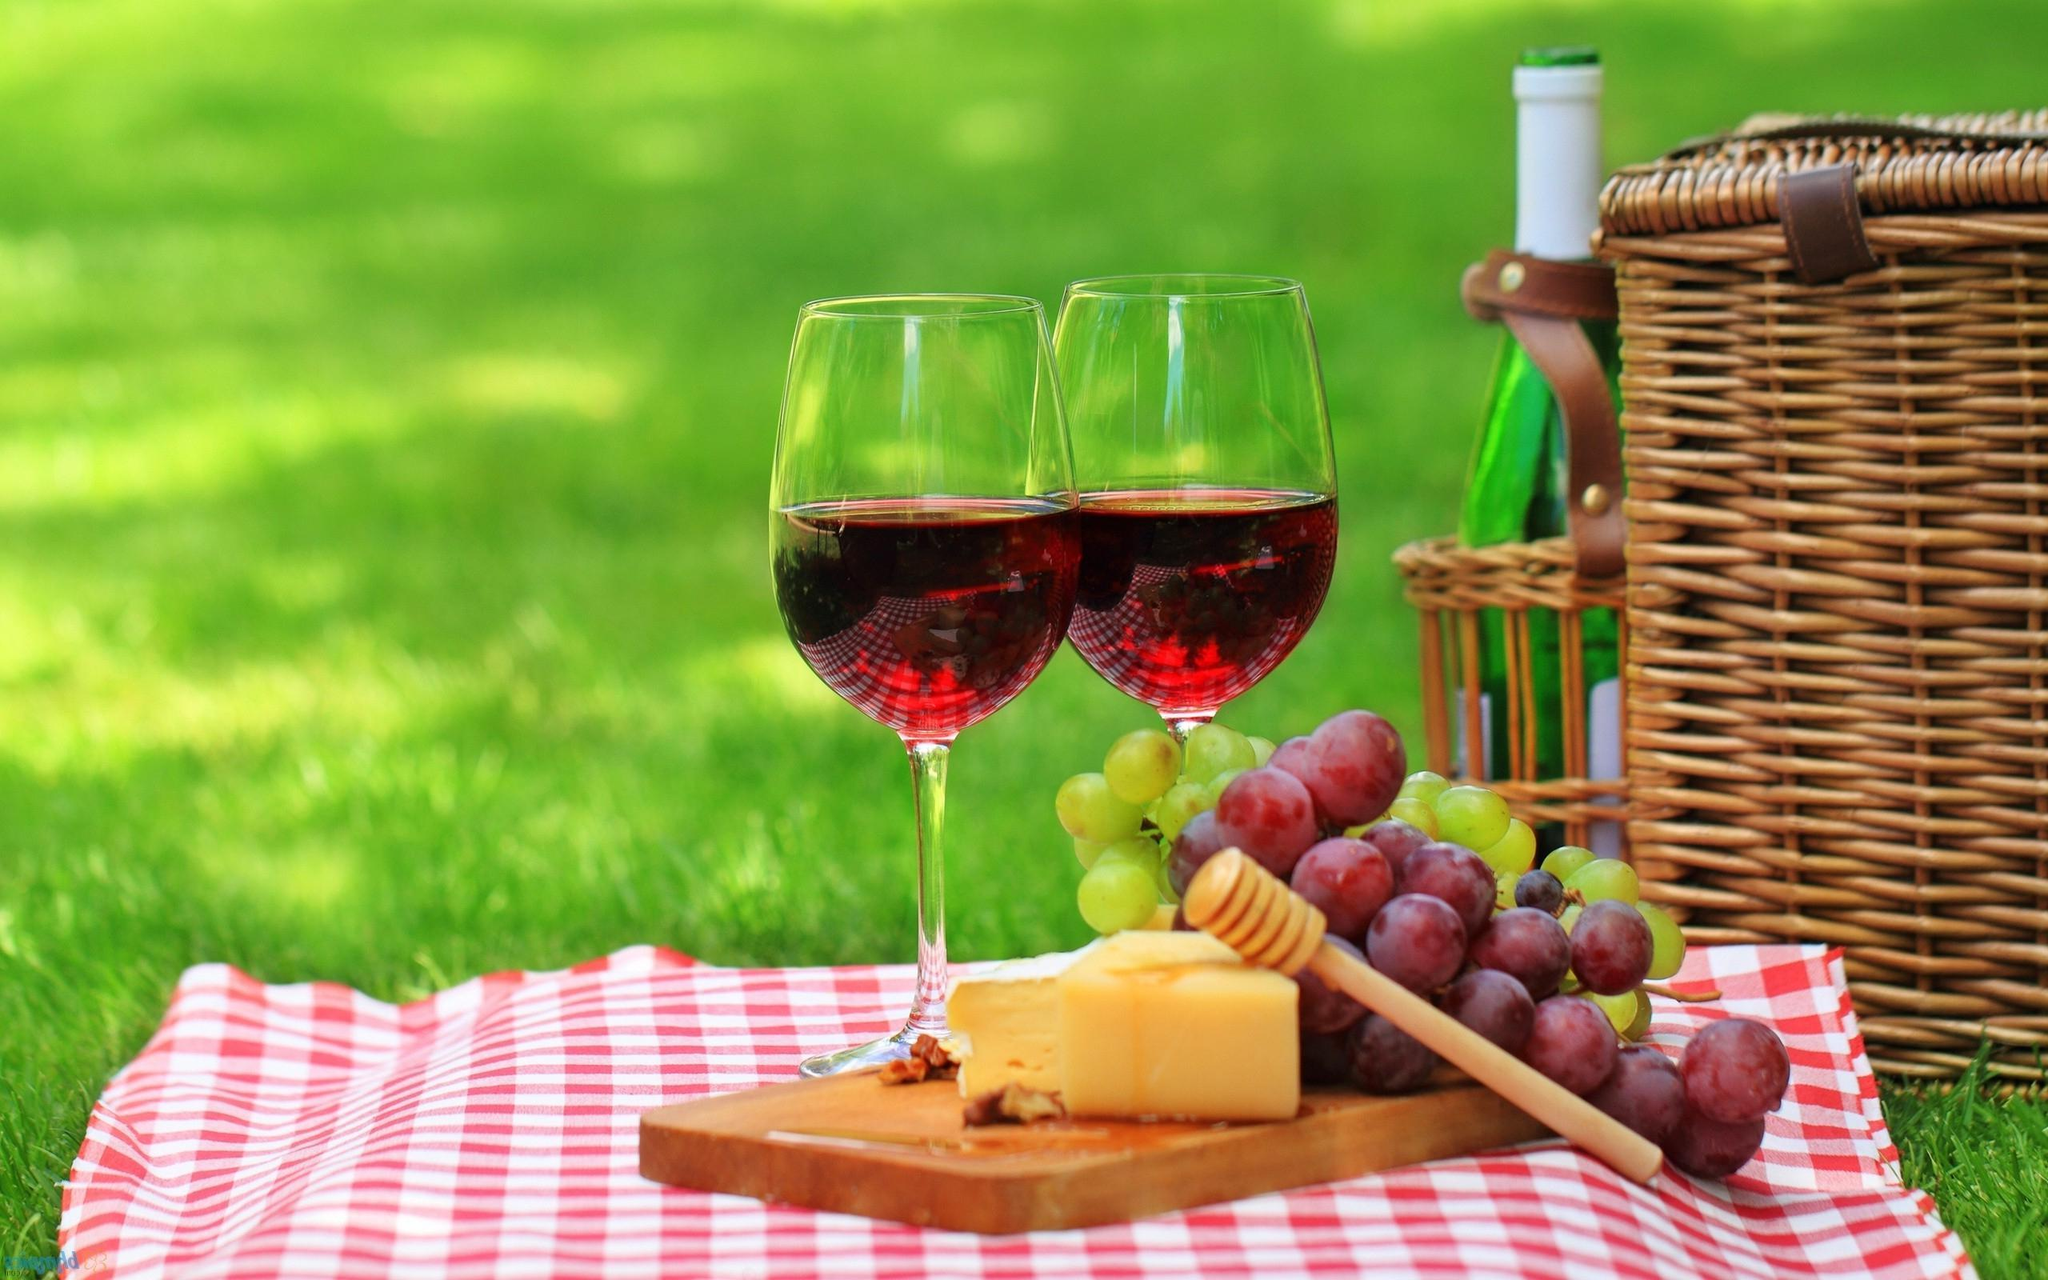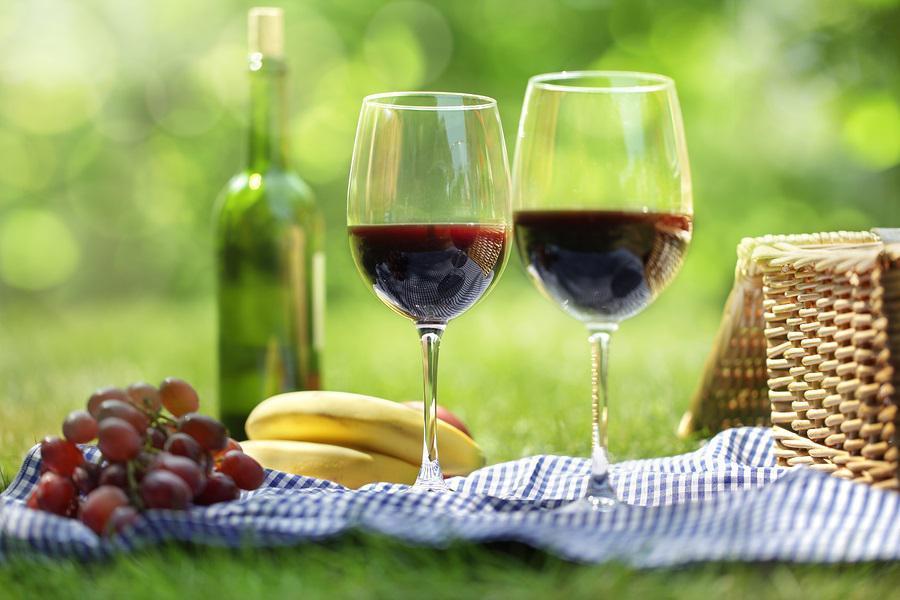The first image is the image on the left, the second image is the image on the right. Assess this claim about the two images: "The wine glasses are near wicker picnic baskets.". Correct or not? Answer yes or no. Yes. 